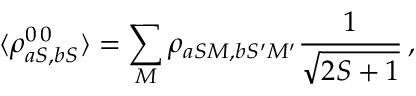Convert formula to latex. <formula><loc_0><loc_0><loc_500><loc_500>\langle \rho _ { a S , b S } ^ { 0 \, 0 } \rangle = \sum _ { M } \rho _ { a S M , b S ^ { \prime } M ^ { \prime } } \frac { 1 } { \sqrt { 2 S + 1 } } \, ,</formula> 